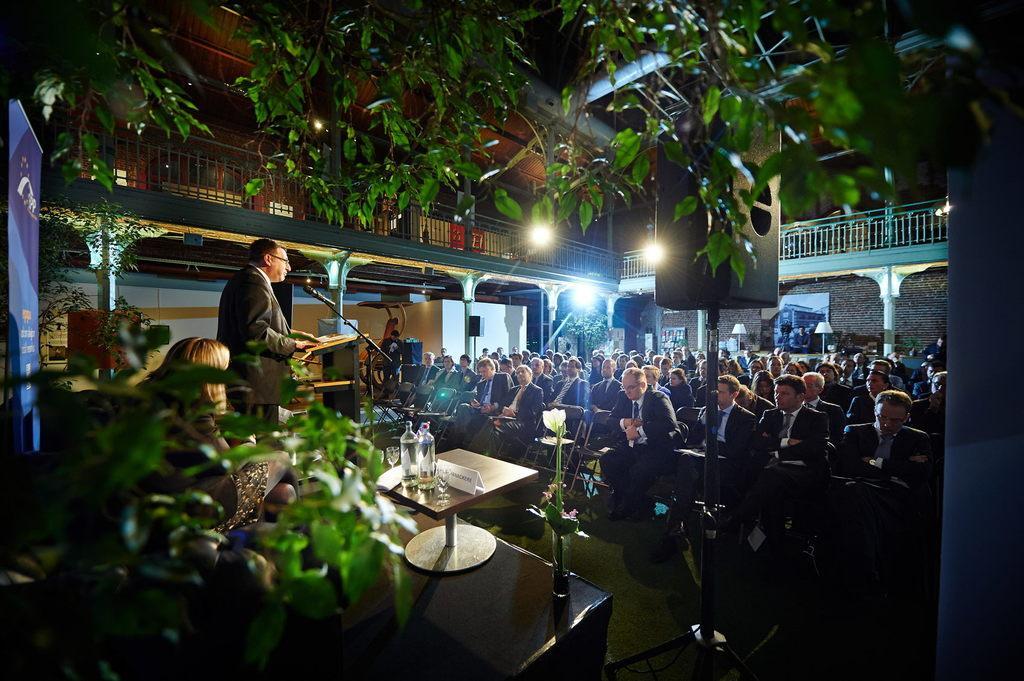In one or two sentences, can you explain what this image depicts? In the image we can see there are many people sitting, they are wearing clothes and some of them are standing. Here we can see the buildings and these are the pillars and fence of the building. Here there is a podium, microphone and bottles on the table. These are the leaves, lights and a dark sky. Here we can see a banner and a floor. 